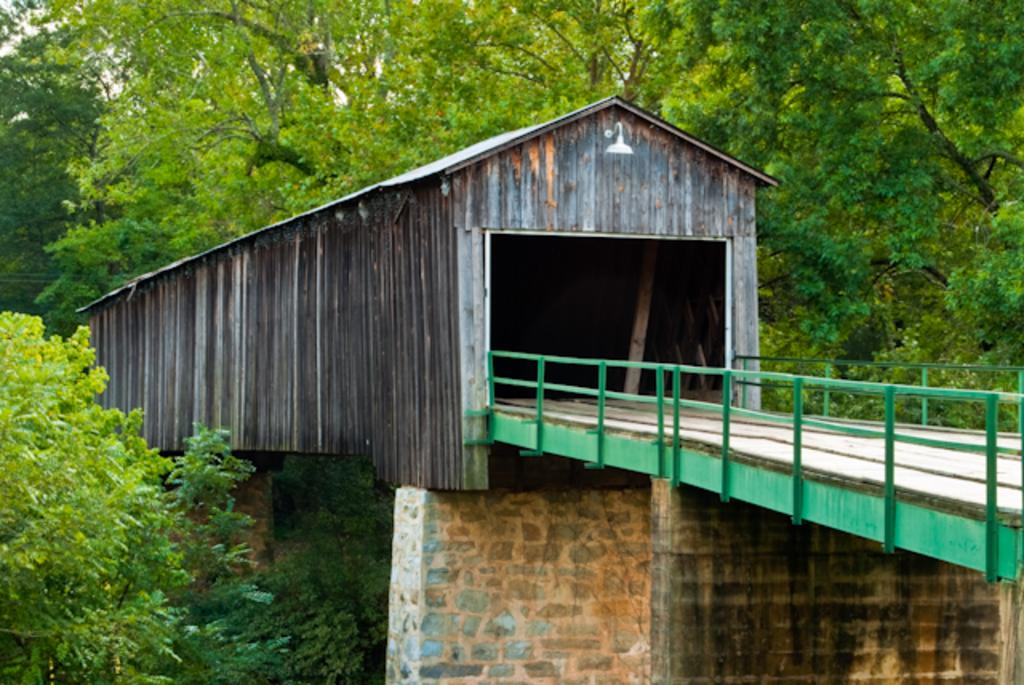What type of structure can be seen in the image? There is a bridge in the image. What other type of structure is present in the image? There is a tunnel in the image. What can be seen in the background of the image? There are trees in the background of the image. What type of beds can be seen in the image? There are no beds present in the image; it features a bridge and a tunnel with trees in the background. 